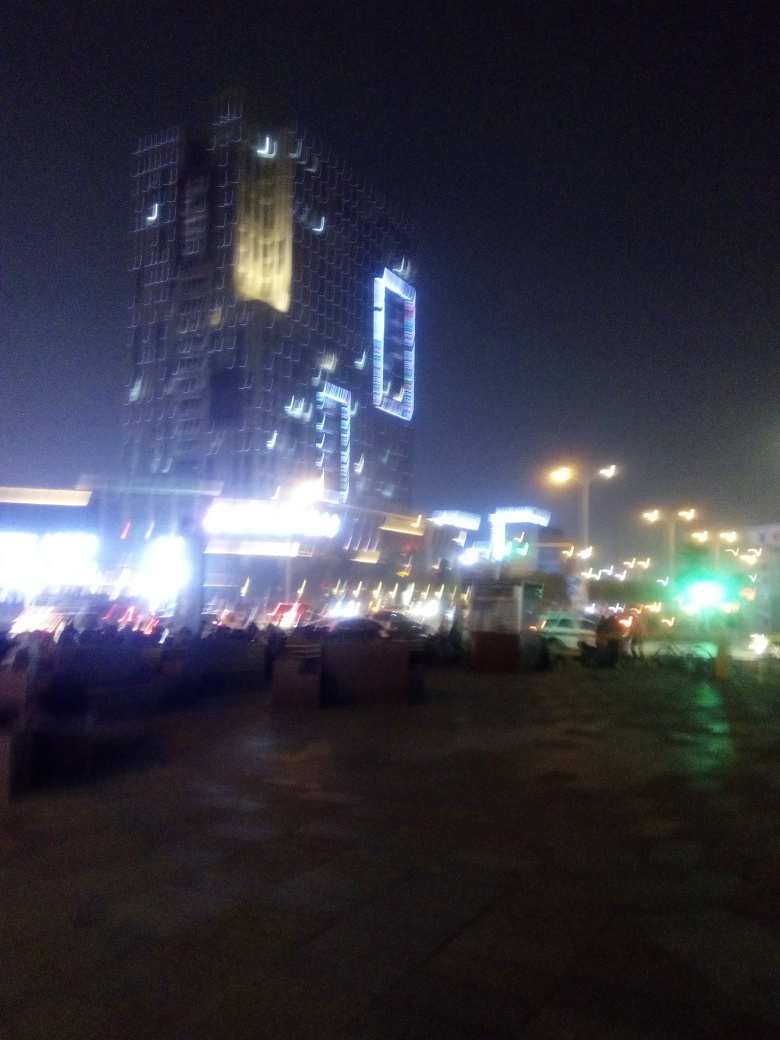Based on the lighting, what kind of activities do you think take place in this area? Given the intense artificial lighting and the prominence of the structures, one might infer that this area supports a range of activities such as dining, shopping, business, or entertainment, typical of a dynamic urban environment at night. 